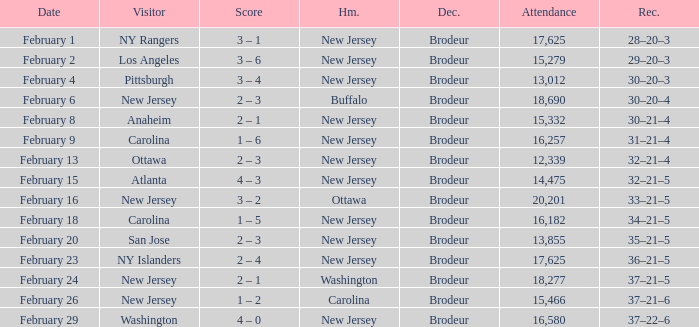What was the score when the NY Islanders was the visiting team? 2 – 4. 